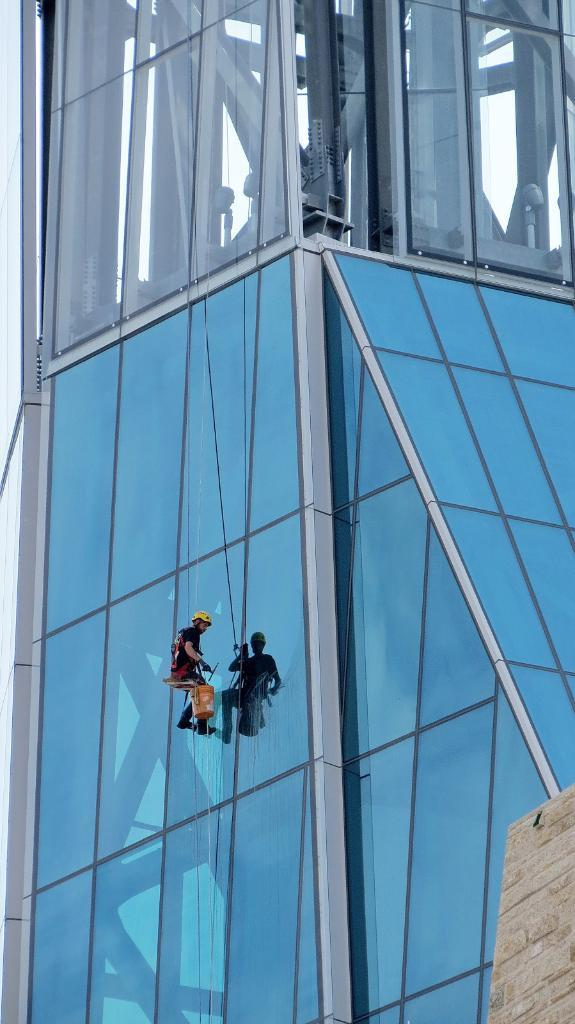Who is the main subject in the image? There is a man in the image. What is the man wearing? The man is wearing an orange dress. What is the man doing in the image? The man is changing and cleaning the building glass. What type of lettuce is being used to clean the building glass in the image? There is no lettuce present in the image; the man is using cleaning materials to clean the glass. 